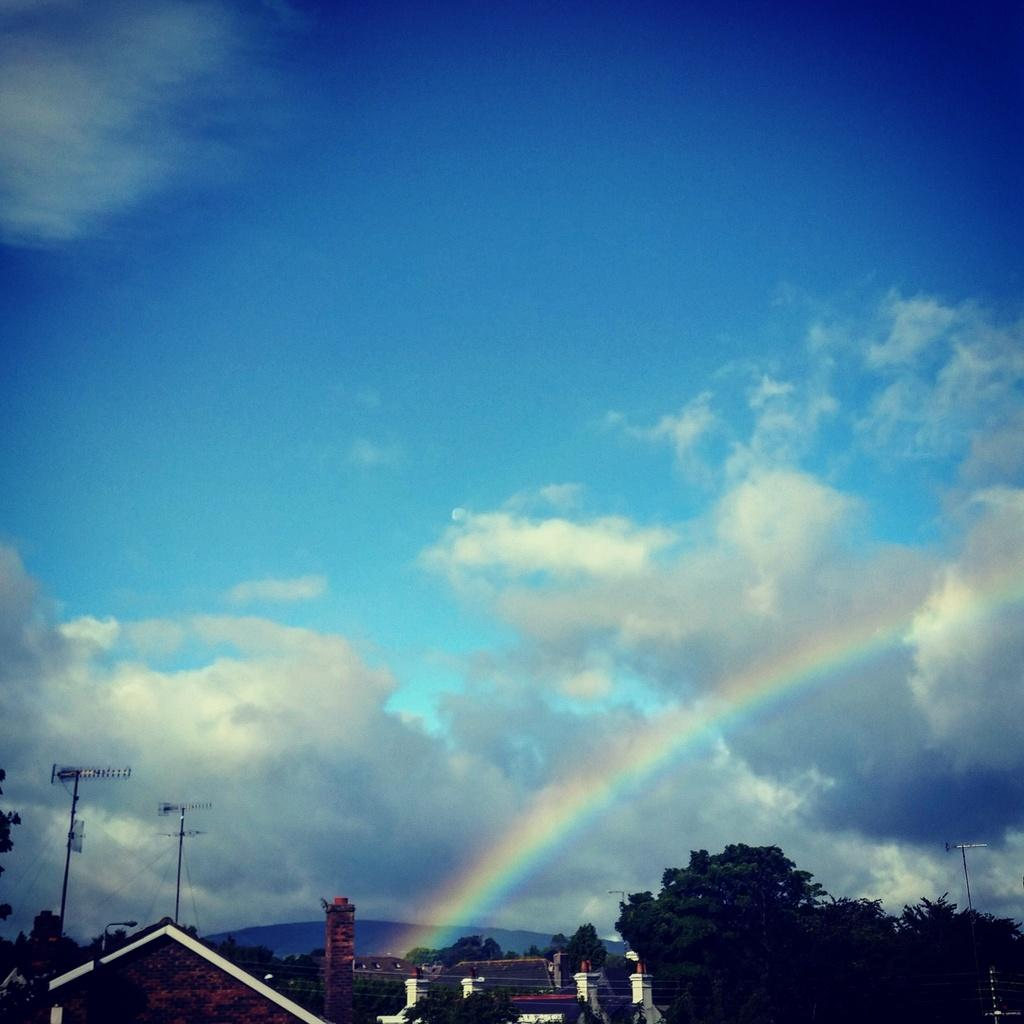What type of natural vegetation is present in the image? There are many trees in the image. What type of structure can be seen in the image? There is a house in the image. What are the tall, thin objects in the image? There are some poles in the image. What is visible in the background of the image? There is a sky visible in the image. What additional feature can be seen in the sky? There is a rainbow in the sky. Can you see any berries hanging from the trees in the image? There is no mention of berries in the image, only trees. Is there a rifle visible in the image? There is no rifle present in the image. 